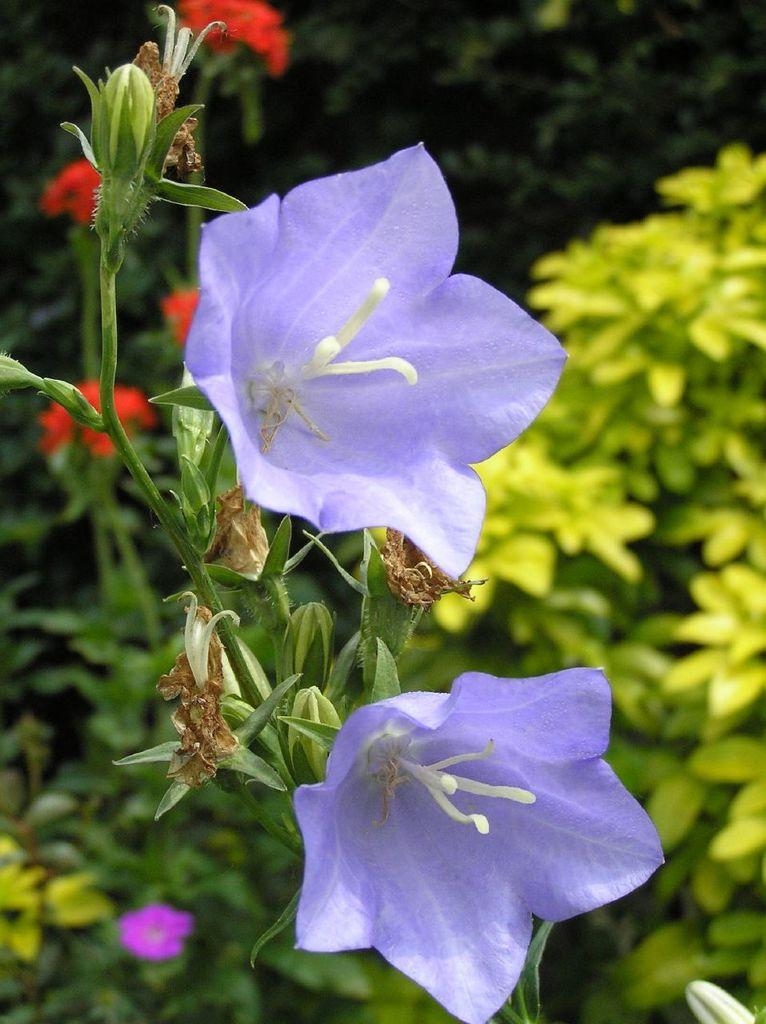What type of objects are in the image that are filled with air? There are two blue balloons in the image. What type of plants can be seen in the image? There are flowers and other flower plants in the image. What type of cart is being used to transport the flowers in the image? There is no cart present in the image; the flowers are not being transported. 